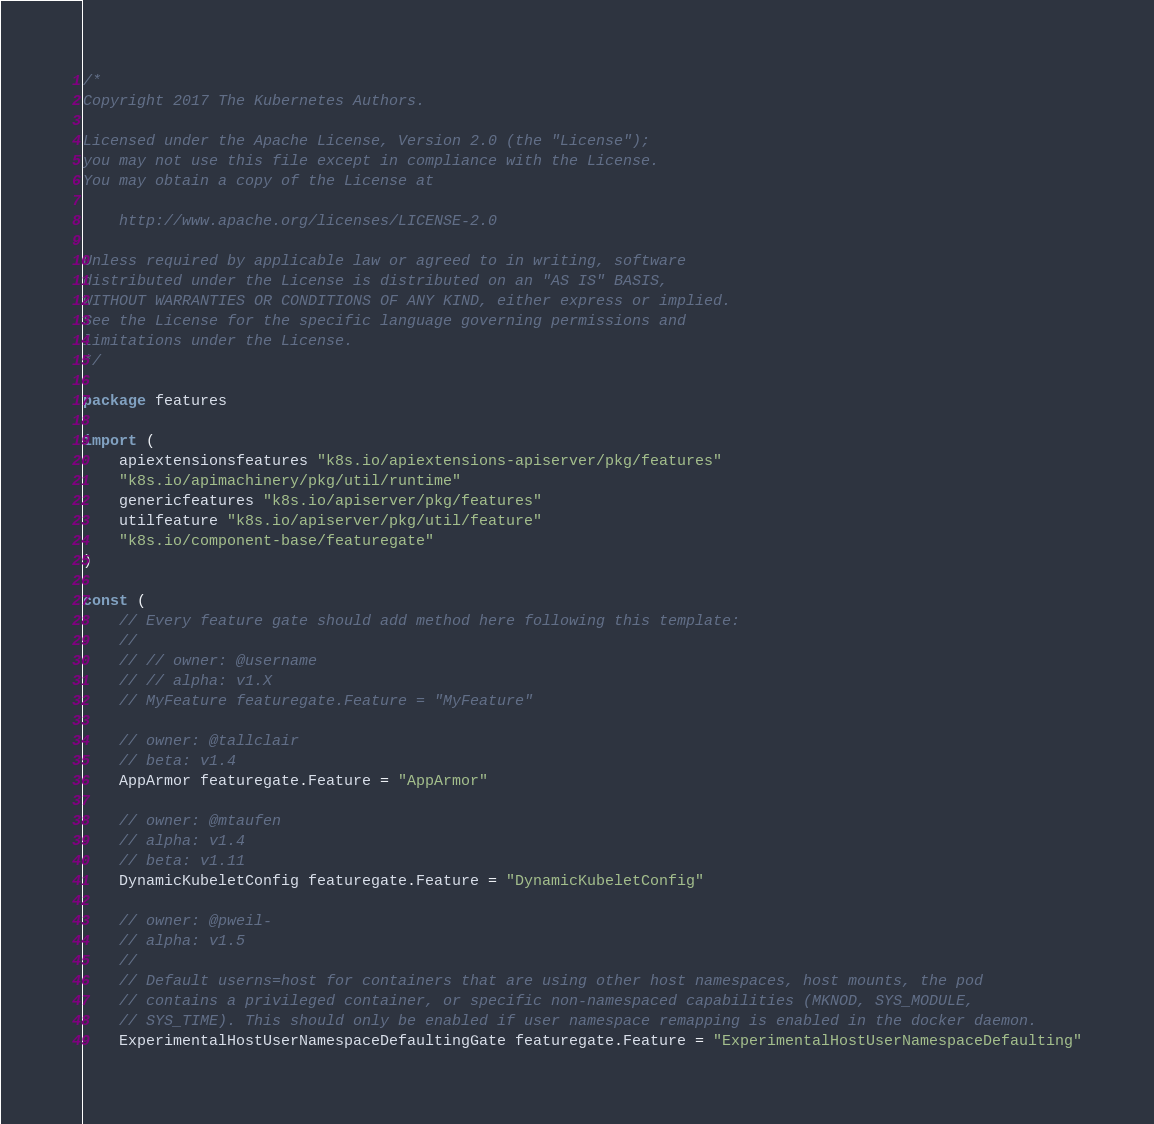Convert code to text. <code><loc_0><loc_0><loc_500><loc_500><_Go_>/*
Copyright 2017 The Kubernetes Authors.

Licensed under the Apache License, Version 2.0 (the "License");
you may not use this file except in compliance with the License.
You may obtain a copy of the License at

    http://www.apache.org/licenses/LICENSE-2.0

Unless required by applicable law or agreed to in writing, software
distributed under the License is distributed on an "AS IS" BASIS,
WITHOUT WARRANTIES OR CONDITIONS OF ANY KIND, either express or implied.
See the License for the specific language governing permissions and
limitations under the License.
*/

package features

import (
	apiextensionsfeatures "k8s.io/apiextensions-apiserver/pkg/features"
	"k8s.io/apimachinery/pkg/util/runtime"
	genericfeatures "k8s.io/apiserver/pkg/features"
	utilfeature "k8s.io/apiserver/pkg/util/feature"
	"k8s.io/component-base/featuregate"
)

const (
	// Every feature gate should add method here following this template:
	//
	// // owner: @username
	// // alpha: v1.X
	// MyFeature featuregate.Feature = "MyFeature"

	// owner: @tallclair
	// beta: v1.4
	AppArmor featuregate.Feature = "AppArmor"

	// owner: @mtaufen
	// alpha: v1.4
	// beta: v1.11
	DynamicKubeletConfig featuregate.Feature = "DynamicKubeletConfig"

	// owner: @pweil-
	// alpha: v1.5
	//
	// Default userns=host for containers that are using other host namespaces, host mounts, the pod
	// contains a privileged container, or specific non-namespaced capabilities (MKNOD, SYS_MODULE,
	// SYS_TIME). This should only be enabled if user namespace remapping is enabled in the docker daemon.
	ExperimentalHostUserNamespaceDefaultingGate featuregate.Feature = "ExperimentalHostUserNamespaceDefaulting"
</code> 